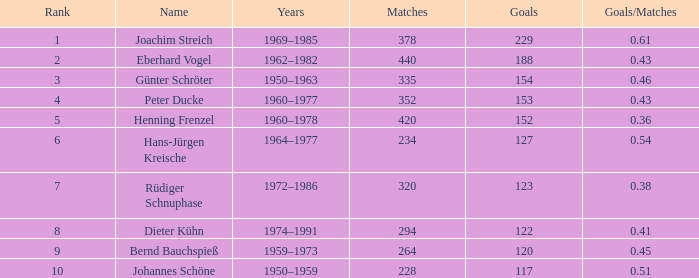What average goals have matches less than 228? None. 